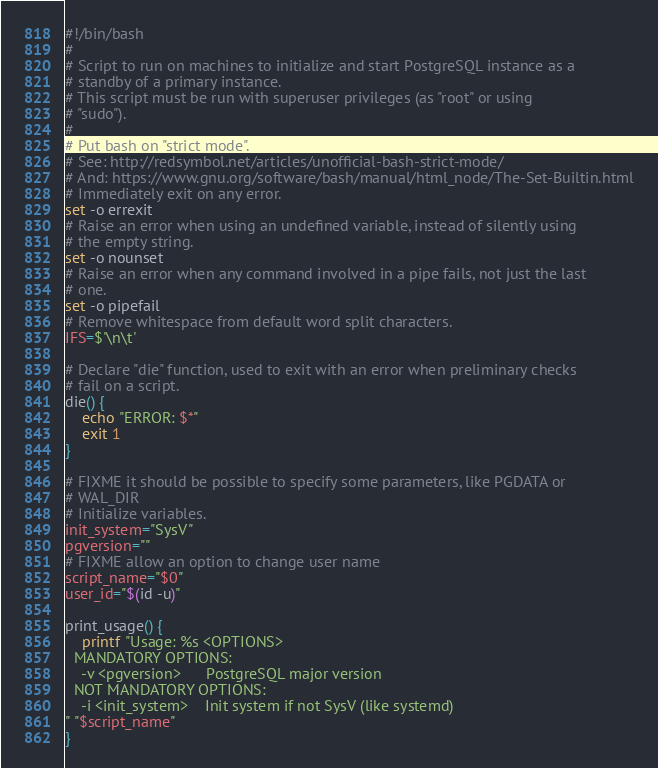Convert code to text. <code><loc_0><loc_0><loc_500><loc_500><_Bash_>#!/bin/bash
#
# Script to run on machines to initialize and start PostgreSQL instance as a
# standby of a primary instance.
# This script must be run with superuser privileges (as "root" or using
# "sudo").
#
# Put bash on "strict mode".
# See: http://redsymbol.net/articles/unofficial-bash-strict-mode/
# And: https://www.gnu.org/software/bash/manual/html_node/The-Set-Builtin.html
# Immediately exit on any error.
set -o errexit
# Raise an error when using an undefined variable, instead of silently using
# the empty string.
set -o nounset
# Raise an error when any command involved in a pipe fails, not just the last
# one.
set -o pipefail
# Remove whitespace from default word split characters.
IFS=$'\n\t'

# Declare "die" function, used to exit with an error when preliminary checks
# fail on a script.
die() {
    echo "ERROR: $*"
    exit 1
}

# FIXME it should be possible to specify some parameters, like PGDATA or
# WAL_DIR
# Initialize variables.
init_system="SysV"
pgversion=""
# FIXME allow an option to change user name
script_name="$0"
user_id="$(id -u)"

print_usage() {
    printf "Usage: %s <OPTIONS>
  MANDATORY OPTIONS:
    -v <pgversion>      PostgreSQL major version
  NOT MANDATORY OPTIONS:
    -i <init_system>    Init system if not SysV (like systemd)
" "$script_name"
}
</code> 